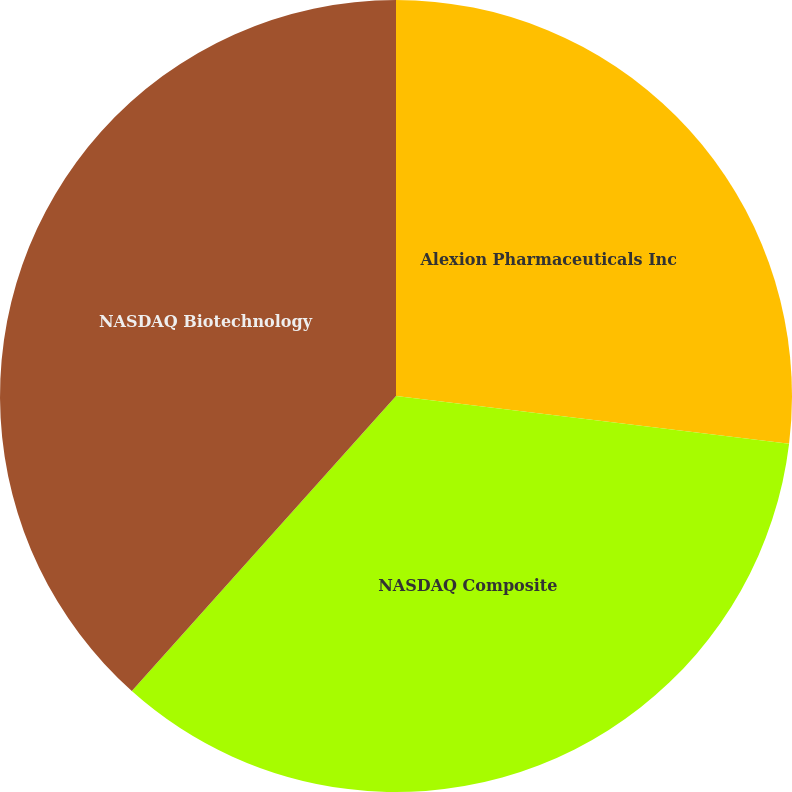Convert chart. <chart><loc_0><loc_0><loc_500><loc_500><pie_chart><fcel>Alexion Pharmaceuticals Inc<fcel>NASDAQ Composite<fcel>NASDAQ Biotechnology<nl><fcel>26.93%<fcel>34.7%<fcel>38.38%<nl></chart> 